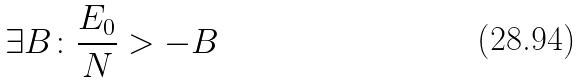<formula> <loc_0><loc_0><loc_500><loc_500>\exists B \colon \frac { E _ { 0 } } { N } > - B</formula> 